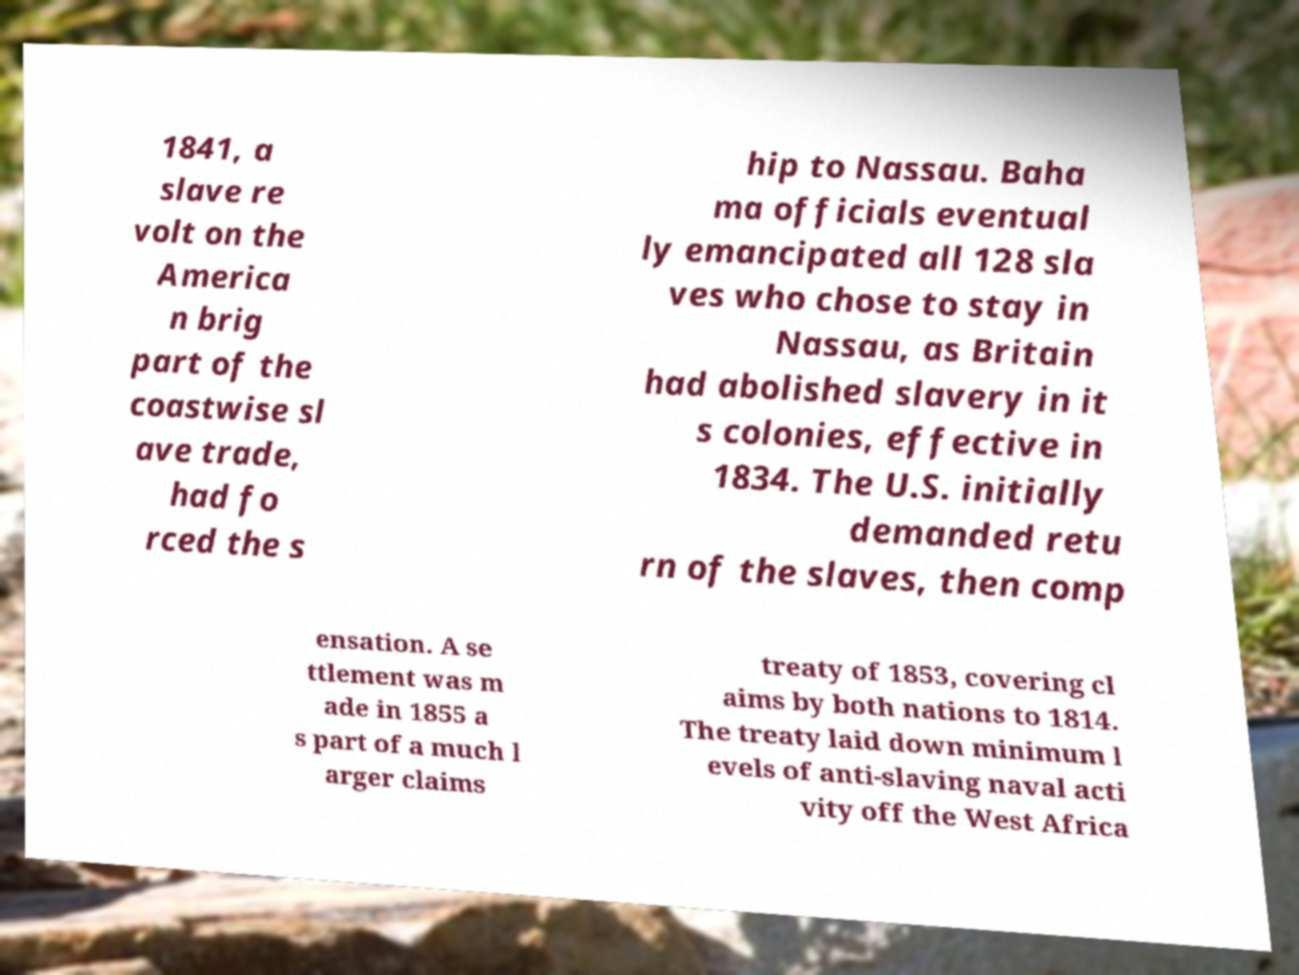Can you accurately transcribe the text from the provided image for me? 1841, a slave re volt on the America n brig part of the coastwise sl ave trade, had fo rced the s hip to Nassau. Baha ma officials eventual ly emancipated all 128 sla ves who chose to stay in Nassau, as Britain had abolished slavery in it s colonies, effective in 1834. The U.S. initially demanded retu rn of the slaves, then comp ensation. A se ttlement was m ade in 1855 a s part of a much l arger claims treaty of 1853, covering cl aims by both nations to 1814. The treaty laid down minimum l evels of anti-slaving naval acti vity off the West Africa 